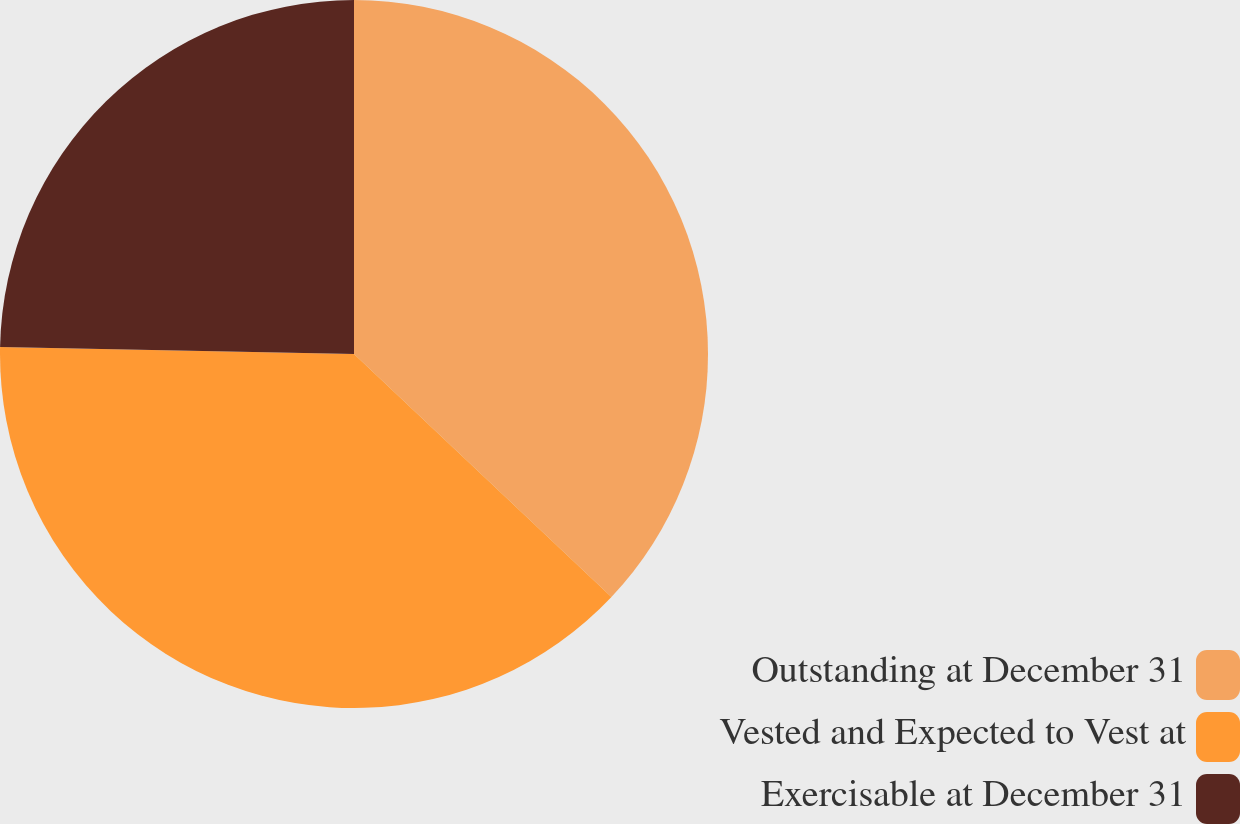<chart> <loc_0><loc_0><loc_500><loc_500><pie_chart><fcel>Outstanding at December 31<fcel>Vested and Expected to Vest at<fcel>Exercisable at December 31<nl><fcel>37.04%<fcel>38.27%<fcel>24.69%<nl></chart> 